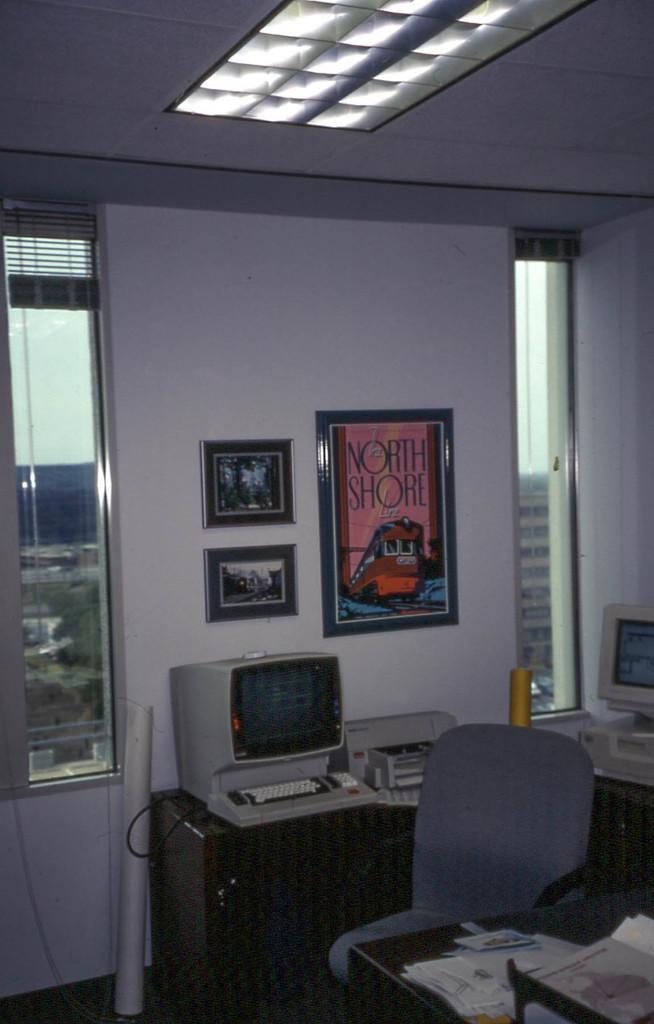<image>
Relay a brief, clear account of the picture shown. Picture that says North Shore inside of an office room. 